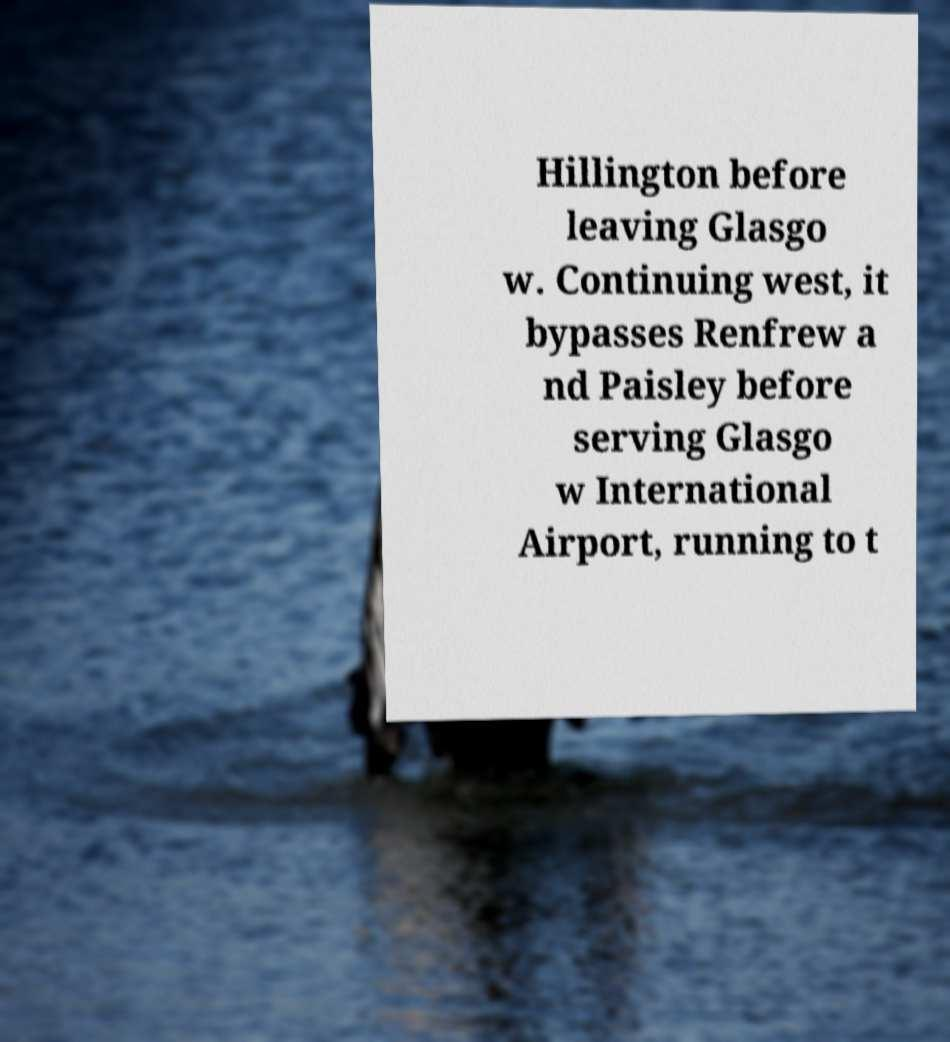Can you accurately transcribe the text from the provided image for me? Hillington before leaving Glasgo w. Continuing west, it bypasses Renfrew a nd Paisley before serving Glasgo w International Airport, running to t 